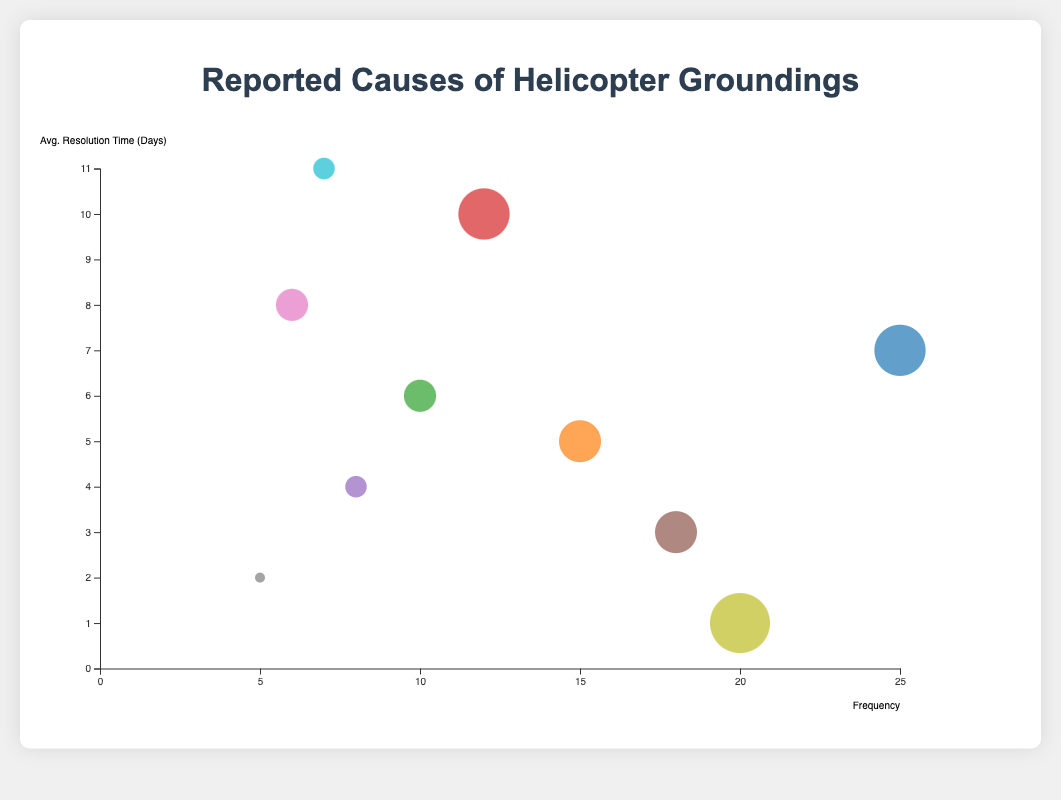Which cause is grounded the most frequently? By looking at the bubble chart, identify the bubble representing the cause with the highest frequency. The bubble representing "Engine Failure" is the largest on the x-axis, indicating it has the highest frequency of 25.
Answer: Engine Failure Which cause has the shortest average resolution time? Examine the y-axis and find the bubble closest to the bottom. The "Overdue Inspections" bubble is nearest to the x-axis, showing an average resolution time of 1 day.
Answer: Overdue Inspections How many causes have an average resolution time of more than 7 days? Count the bubbles on the chart that are positioned above the y-axis value of 7. "Engine Failure," "Rotor Blade Damage," "Weather-Related Damages," and "Transmission Issues" are above 7 days.
Answer: 4 Which cause has the highest importance level? By observing the bubble sizes since importance is related to bubble size, "Overdue Inspections" shows the largest bubble, indicating an importance of 10.
Answer: Overdue Inspections What is the average resolution time for Hydraulic System Malfunction and Avionics Failure combined? Add the average resolution times of the two causes and divide by 2. Hydraulic System Malfunction is 5 days, and Avionics Failure is 6 days, so (5 + 6) / 2 = 5.5 days.
Answer: 5.5 Which has a greater average resolution time, Rotor Blade Damage or Weather-Related Damages? Compare the positions of the "Rotor Blade Damage" and "Weather-Related Damages" bubbles on the y-axis. Rotor Blade Damage takes 10 days, whereas Weather-Related Damages take 11 days.
Answer: Weather-Related Damages Compare Frequency between Electrical System Failure and Avionics Failure, which is grounded more frequently? Locate the bubbles for both causes and compare their x-axis positions. Electrical System Failure has a frequency of 18, while Avionics Failure has a frequency of 10.
Answer: Electrical System Failure What is the importance level of the cause with the longest average resolution time? Identify the bubble highest on the y-axis and note its size. "Weather-Related Damages" has the longest average resolution time of 11 days and an importance level of 6.
Answer: 6 What is the combined importance of all causes with an average resolution time of less than 5 days? Identify the bubbles below the 5-day mark on the y-axis and sum their importances. These causes are "Electrical System Failure" (8), "Landing Gear Malfunction" (5), and "Overdue Inspections" (10). The total importance is 8 + 5 + 10 = 23.
Answer: 23 